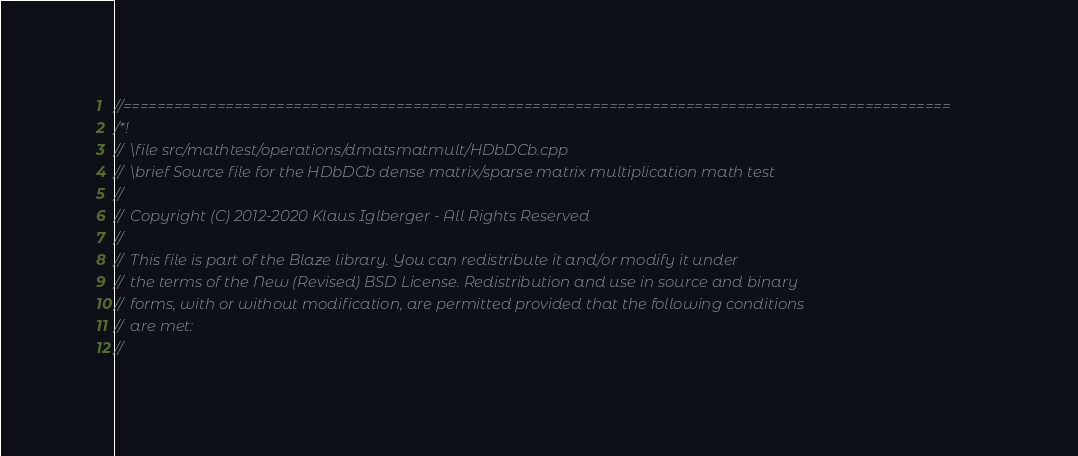Convert code to text. <code><loc_0><loc_0><loc_500><loc_500><_C++_>//=================================================================================================
/*!
//  \file src/mathtest/operations/dmatsmatmult/HDbDCb.cpp
//  \brief Source file for the HDbDCb dense matrix/sparse matrix multiplication math test
//
//  Copyright (C) 2012-2020 Klaus Iglberger - All Rights Reserved
//
//  This file is part of the Blaze library. You can redistribute it and/or modify it under
//  the terms of the New (Revised) BSD License. Redistribution and use in source and binary
//  forms, with or without modification, are permitted provided that the following conditions
//  are met:
//</code> 